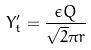<formula> <loc_0><loc_0><loc_500><loc_500>Y _ { t } ^ { \prime } = \frac { \epsilon Q } { \sqrt { 2 } \pi r }</formula> 